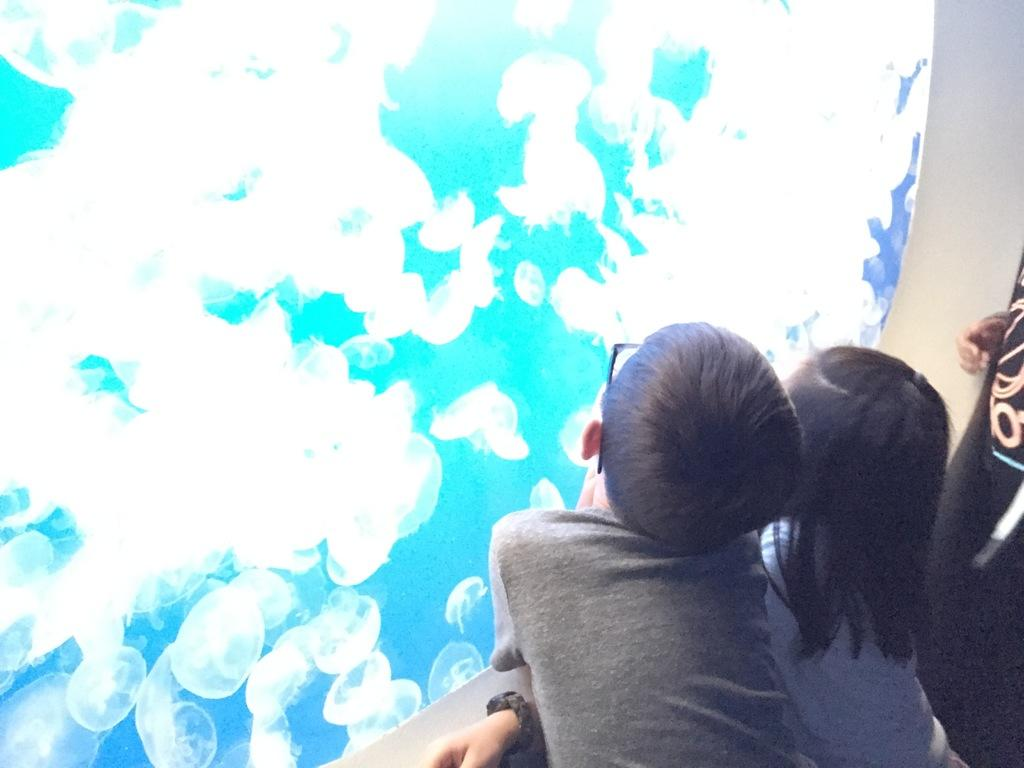Who are the people in the image? There is a boy and a girl in the image. What are the boy and the girl doing? They are both standing and watching inside an aquarium. Can you describe their positions in the image? They are standing next to each other, facing the aquarium. What type of crack can be seen in the image? There is no crack present in the image. Is there any coal visible in the image? There is no coal present in the image. 